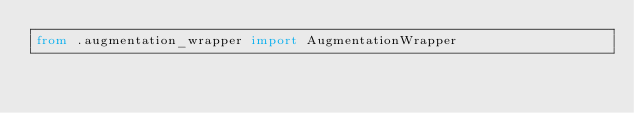Convert code to text. <code><loc_0><loc_0><loc_500><loc_500><_Python_>from .augmentation_wrapper import AugmentationWrapper
</code> 